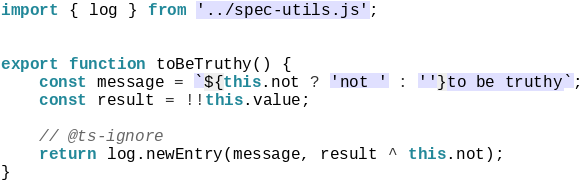<code> <loc_0><loc_0><loc_500><loc_500><_JavaScript_>import { log } from '../spec-utils.js';


export function toBeTruthy() {
	const message = `${this.not ? 'not ' : ''}to be truthy`;
	const result = !!this.value;

	// @ts-ignore
	return log.newEntry(message, result ^ this.not);
}
</code> 